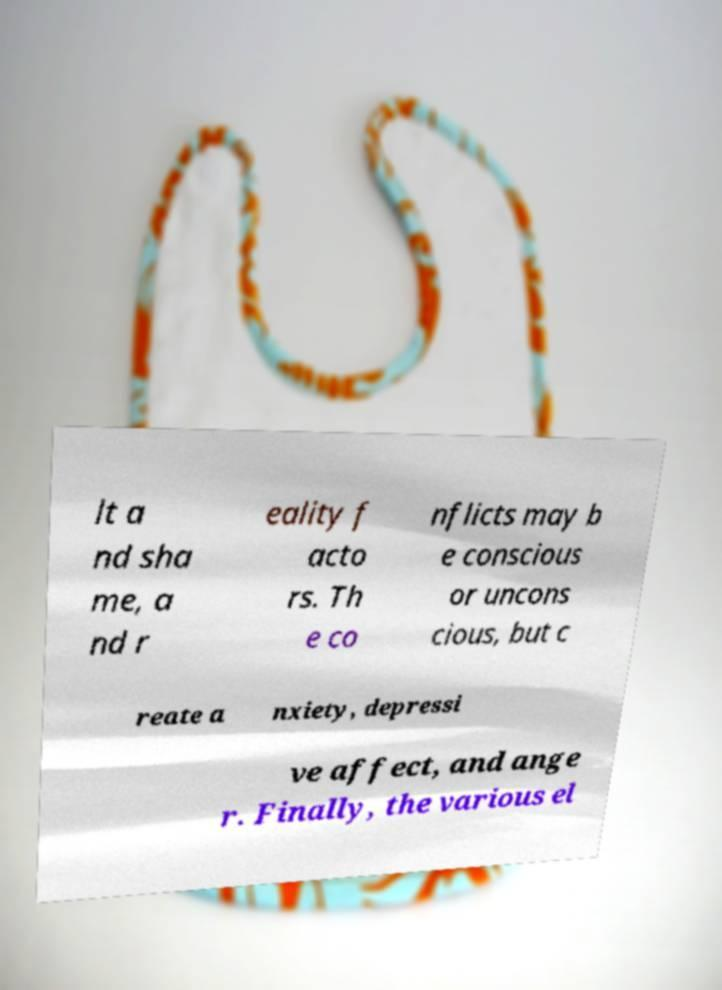Please read and relay the text visible in this image. What does it say? lt a nd sha me, a nd r eality f acto rs. Th e co nflicts may b e conscious or uncons cious, but c reate a nxiety, depressi ve affect, and ange r. Finally, the various el 